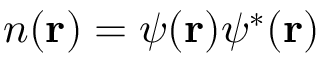<formula> <loc_0><loc_0><loc_500><loc_500>n ( { r } ) = \psi ( { r } ) \psi ^ { * } ( { r } )</formula> 